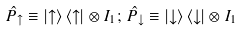<formula> <loc_0><loc_0><loc_500><loc_500>\hat { P } _ { \uparrow } \equiv | { \uparrow } \rangle \, \langle { \uparrow } | \otimes I _ { 1 } ; \, \hat { P } _ { \downarrow } \equiv | { \downarrow } \rangle \, \langle { \downarrow } | \otimes I _ { 1 }</formula> 